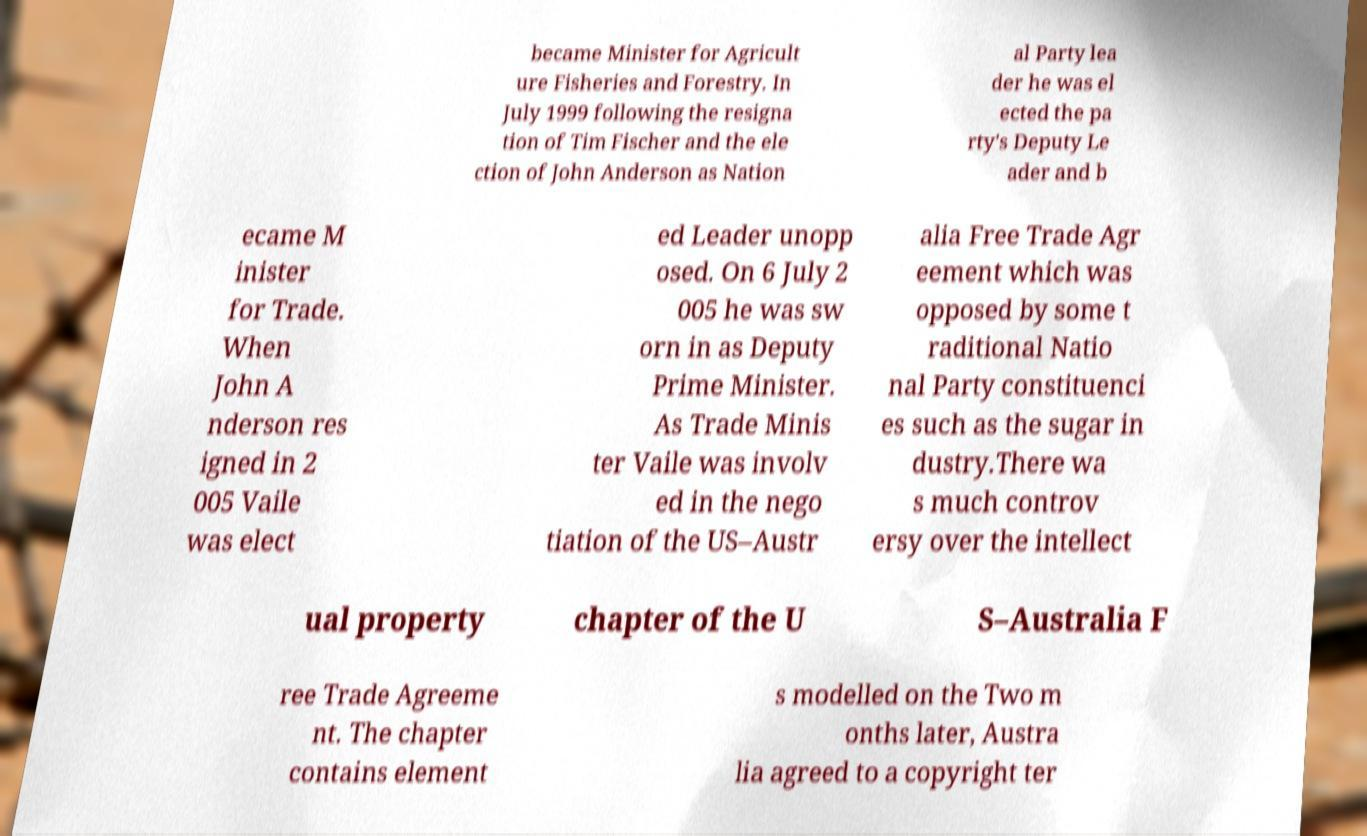Please identify and transcribe the text found in this image. became Minister for Agricult ure Fisheries and Forestry. In July 1999 following the resigna tion of Tim Fischer and the ele ction of John Anderson as Nation al Party lea der he was el ected the pa rty's Deputy Le ader and b ecame M inister for Trade. When John A nderson res igned in 2 005 Vaile was elect ed Leader unopp osed. On 6 July 2 005 he was sw orn in as Deputy Prime Minister. As Trade Minis ter Vaile was involv ed in the nego tiation of the US–Austr alia Free Trade Agr eement which was opposed by some t raditional Natio nal Party constituenci es such as the sugar in dustry.There wa s much controv ersy over the intellect ual property chapter of the U S–Australia F ree Trade Agreeme nt. The chapter contains element s modelled on the Two m onths later, Austra lia agreed to a copyright ter 